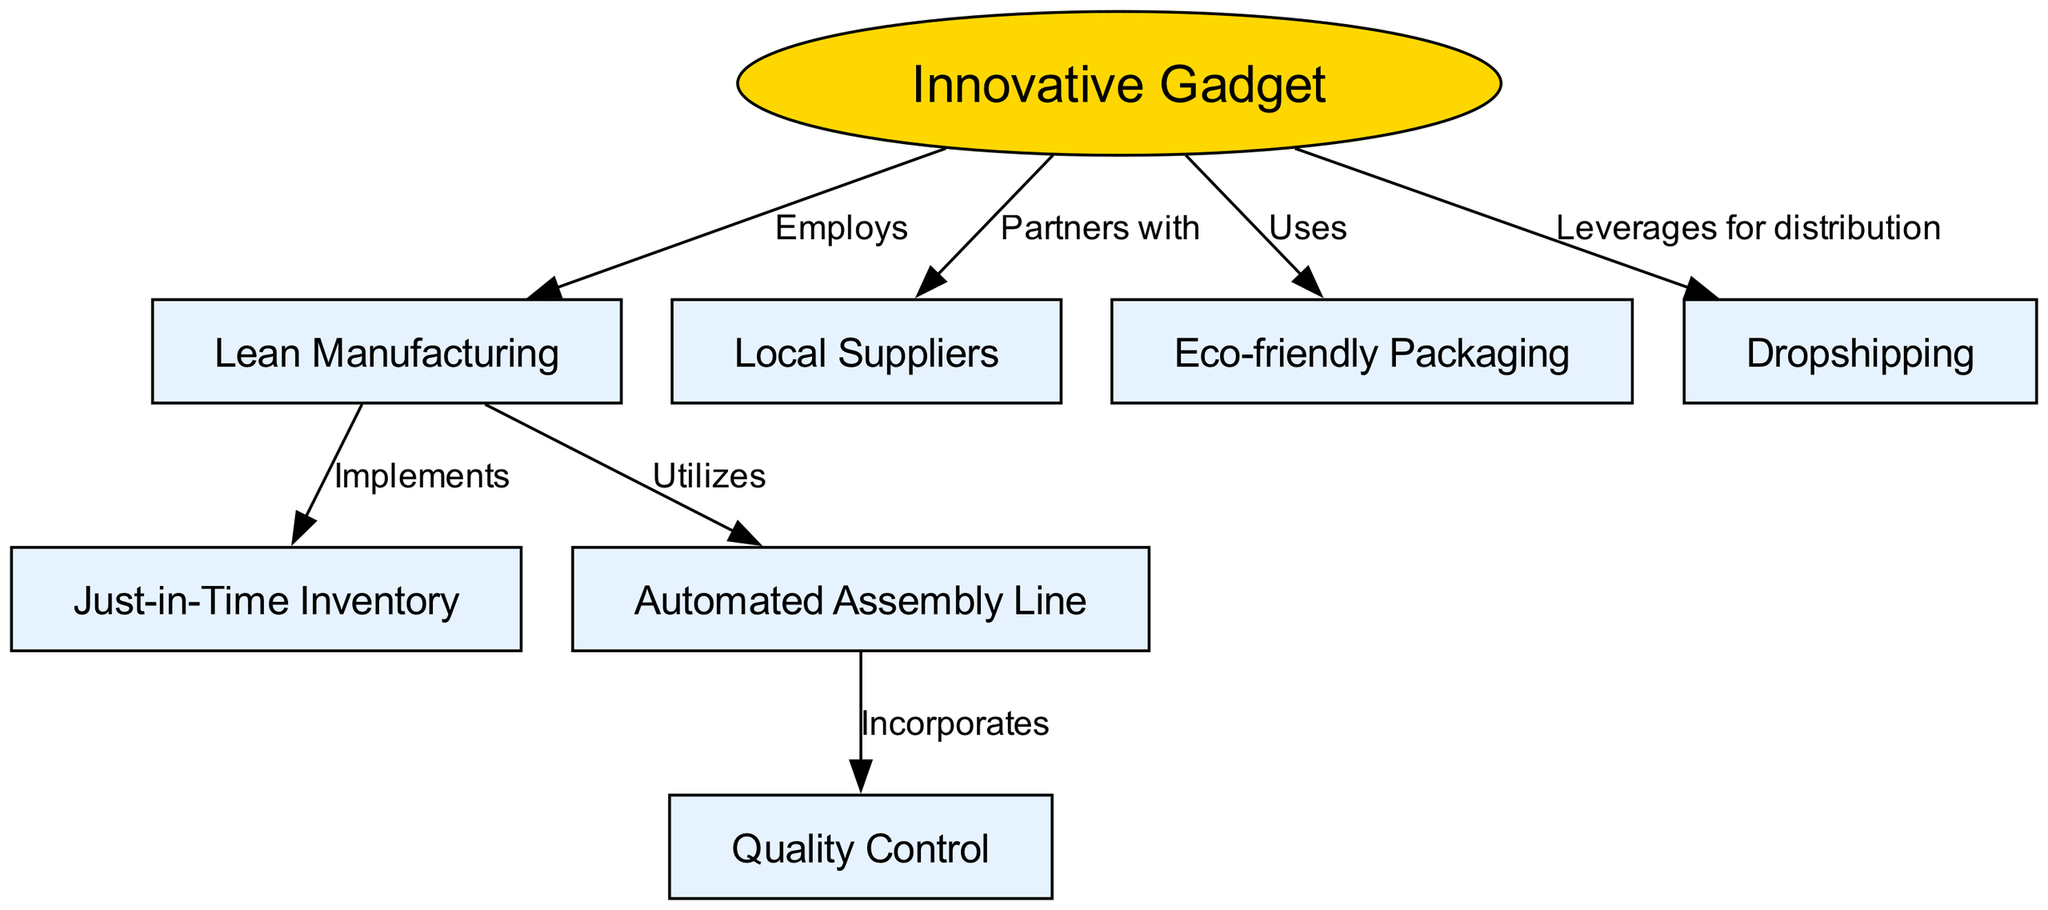What is the main product of the startup? The main product is identified as the "Innovative Gadget," which is the central node in the diagram and serves as the starting point for other associations.
Answer: Innovative Gadget How many nodes are present in the diagram? The diagram contains eight nodes, representing different aspects of the manufacturing process and supply chain optimization.
Answer: Eight What does the "Innovative Gadget" partner with for supplies? The diagram shows that the "Innovative Gadget" partners with "Local Suppliers." This is directly represented in a connection from the main product node to the local suppliers node.
Answer: Local Suppliers Which manufacturing strategy does the startup utilize? The startup employs "Lean Manufacturing" as indicated by the direct connection labeled "Employs" from the "Innovative Gadget" to "Lean Manufacturing."
Answer: Lean Manufacturing What type of inventory strategy is implemented? The diagram indicates that the strategy implemented is "Just-in-Time Inventory," which follows directly from the "Lean Manufacturing" node, as shown in the connection labeled "Implements."
Answer: Just-in-Time Inventory How does the startup ensure product quality? Quality is ensured through "Quality Control," which is linked to the "Automated Assembly Line," indicating that the assembly line incorporates measures for quality assessment.
Answer: Quality Control What is incorporated into the assembly line? The "Automated Assembly Line" incorporates "Quality Control," indicating that there are elements or processes that help monitor and ensure quality during production.
Answer: Quality Control What kind of distribution method does the startup leverage? The startup leverages "Dropshipping" for distribution as indicated by the connection labeled "Leverages for distribution" from "Innovative Gadget" to "Dropshipping."
Answer: Dropshipping What kind of packaging does the startup use? According to the diagram, the startup uses "Eco-friendly Packaging," which is directly connected to the main product node "Innovative Gadget."
Answer: Eco-friendly Packaging 